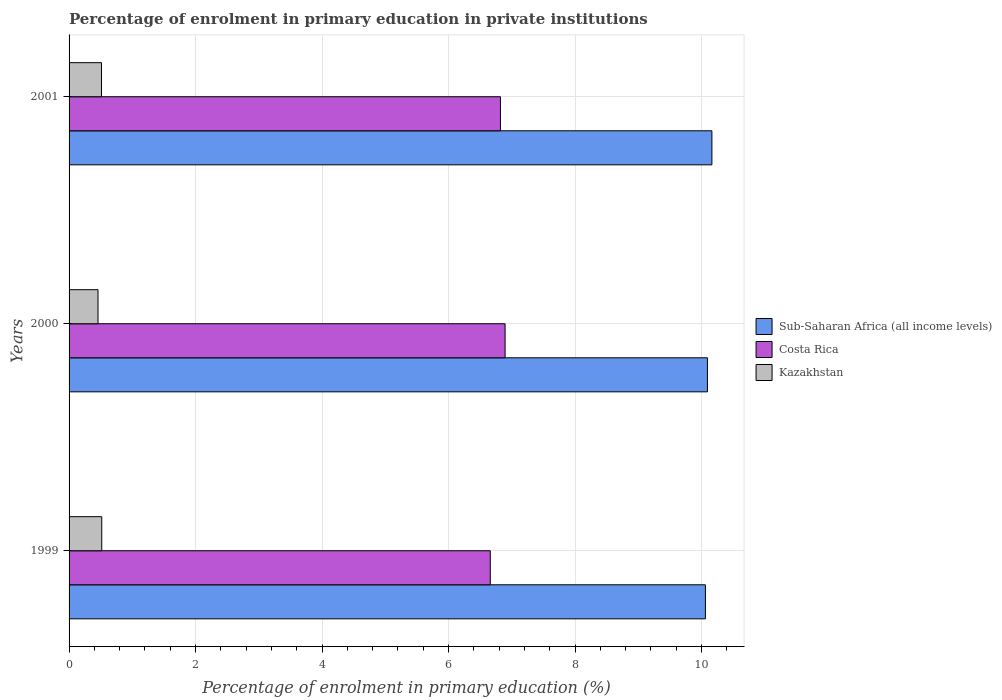How many groups of bars are there?
Your answer should be very brief. 3. Are the number of bars per tick equal to the number of legend labels?
Your response must be concise. Yes. Are the number of bars on each tick of the Y-axis equal?
Your response must be concise. Yes. How many bars are there on the 2nd tick from the top?
Offer a very short reply. 3. What is the label of the 1st group of bars from the top?
Your answer should be compact. 2001. What is the percentage of enrolment in primary education in Costa Rica in 2001?
Keep it short and to the point. 6.82. Across all years, what is the maximum percentage of enrolment in primary education in Sub-Saharan Africa (all income levels)?
Provide a succinct answer. 10.16. Across all years, what is the minimum percentage of enrolment in primary education in Costa Rica?
Your answer should be very brief. 6.66. What is the total percentage of enrolment in primary education in Kazakhstan in the graph?
Make the answer very short. 1.49. What is the difference between the percentage of enrolment in primary education in Costa Rica in 2000 and that in 2001?
Offer a terse response. 0.07. What is the difference between the percentage of enrolment in primary education in Sub-Saharan Africa (all income levels) in 2000 and the percentage of enrolment in primary education in Costa Rica in 2001?
Your answer should be very brief. 3.27. What is the average percentage of enrolment in primary education in Kazakhstan per year?
Make the answer very short. 0.5. In the year 2000, what is the difference between the percentage of enrolment in primary education in Costa Rica and percentage of enrolment in primary education in Kazakhstan?
Offer a terse response. 6.44. What is the ratio of the percentage of enrolment in primary education in Kazakhstan in 2000 to that in 2001?
Provide a succinct answer. 0.89. Is the difference between the percentage of enrolment in primary education in Costa Rica in 1999 and 2001 greater than the difference between the percentage of enrolment in primary education in Kazakhstan in 1999 and 2001?
Make the answer very short. No. What is the difference between the highest and the second highest percentage of enrolment in primary education in Sub-Saharan Africa (all income levels)?
Your answer should be very brief. 0.07. What is the difference between the highest and the lowest percentage of enrolment in primary education in Costa Rica?
Your answer should be compact. 0.23. In how many years, is the percentage of enrolment in primary education in Kazakhstan greater than the average percentage of enrolment in primary education in Kazakhstan taken over all years?
Your answer should be very brief. 2. What does the 1st bar from the top in 2001 represents?
Ensure brevity in your answer.  Kazakhstan. Is it the case that in every year, the sum of the percentage of enrolment in primary education in Sub-Saharan Africa (all income levels) and percentage of enrolment in primary education in Costa Rica is greater than the percentage of enrolment in primary education in Kazakhstan?
Your answer should be very brief. Yes. How many bars are there?
Give a very brief answer. 9. Are all the bars in the graph horizontal?
Your response must be concise. Yes. How many years are there in the graph?
Offer a terse response. 3. Are the values on the major ticks of X-axis written in scientific E-notation?
Your response must be concise. No. Does the graph contain grids?
Make the answer very short. Yes. How are the legend labels stacked?
Your answer should be very brief. Vertical. What is the title of the graph?
Make the answer very short. Percentage of enrolment in primary education in private institutions. What is the label or title of the X-axis?
Your response must be concise. Percentage of enrolment in primary education (%). What is the label or title of the Y-axis?
Your answer should be very brief. Years. What is the Percentage of enrolment in primary education (%) in Sub-Saharan Africa (all income levels) in 1999?
Keep it short and to the point. 10.06. What is the Percentage of enrolment in primary education (%) of Costa Rica in 1999?
Provide a succinct answer. 6.66. What is the Percentage of enrolment in primary education (%) in Kazakhstan in 1999?
Your answer should be compact. 0.52. What is the Percentage of enrolment in primary education (%) in Sub-Saharan Africa (all income levels) in 2000?
Provide a short and direct response. 10.09. What is the Percentage of enrolment in primary education (%) of Costa Rica in 2000?
Keep it short and to the point. 6.89. What is the Percentage of enrolment in primary education (%) of Kazakhstan in 2000?
Ensure brevity in your answer.  0.46. What is the Percentage of enrolment in primary education (%) of Sub-Saharan Africa (all income levels) in 2001?
Offer a terse response. 10.16. What is the Percentage of enrolment in primary education (%) in Costa Rica in 2001?
Your answer should be compact. 6.82. What is the Percentage of enrolment in primary education (%) of Kazakhstan in 2001?
Offer a very short reply. 0.51. Across all years, what is the maximum Percentage of enrolment in primary education (%) in Sub-Saharan Africa (all income levels)?
Keep it short and to the point. 10.16. Across all years, what is the maximum Percentage of enrolment in primary education (%) in Costa Rica?
Provide a short and direct response. 6.89. Across all years, what is the maximum Percentage of enrolment in primary education (%) in Kazakhstan?
Your answer should be compact. 0.52. Across all years, what is the minimum Percentage of enrolment in primary education (%) in Sub-Saharan Africa (all income levels)?
Make the answer very short. 10.06. Across all years, what is the minimum Percentage of enrolment in primary education (%) of Costa Rica?
Your answer should be compact. 6.66. Across all years, what is the minimum Percentage of enrolment in primary education (%) of Kazakhstan?
Your answer should be compact. 0.46. What is the total Percentage of enrolment in primary education (%) of Sub-Saharan Africa (all income levels) in the graph?
Your answer should be very brief. 30.32. What is the total Percentage of enrolment in primary education (%) in Costa Rica in the graph?
Provide a short and direct response. 20.37. What is the total Percentage of enrolment in primary education (%) in Kazakhstan in the graph?
Ensure brevity in your answer.  1.49. What is the difference between the Percentage of enrolment in primary education (%) in Sub-Saharan Africa (all income levels) in 1999 and that in 2000?
Give a very brief answer. -0.03. What is the difference between the Percentage of enrolment in primary education (%) of Costa Rica in 1999 and that in 2000?
Your answer should be very brief. -0.23. What is the difference between the Percentage of enrolment in primary education (%) of Kazakhstan in 1999 and that in 2000?
Ensure brevity in your answer.  0.06. What is the difference between the Percentage of enrolment in primary education (%) in Sub-Saharan Africa (all income levels) in 1999 and that in 2001?
Ensure brevity in your answer.  -0.1. What is the difference between the Percentage of enrolment in primary education (%) in Costa Rica in 1999 and that in 2001?
Make the answer very short. -0.16. What is the difference between the Percentage of enrolment in primary education (%) of Kazakhstan in 1999 and that in 2001?
Provide a succinct answer. 0. What is the difference between the Percentage of enrolment in primary education (%) in Sub-Saharan Africa (all income levels) in 2000 and that in 2001?
Your response must be concise. -0.07. What is the difference between the Percentage of enrolment in primary education (%) of Costa Rica in 2000 and that in 2001?
Your answer should be compact. 0.07. What is the difference between the Percentage of enrolment in primary education (%) of Kazakhstan in 2000 and that in 2001?
Offer a terse response. -0.05. What is the difference between the Percentage of enrolment in primary education (%) in Sub-Saharan Africa (all income levels) in 1999 and the Percentage of enrolment in primary education (%) in Costa Rica in 2000?
Provide a succinct answer. 3.17. What is the difference between the Percentage of enrolment in primary education (%) of Sub-Saharan Africa (all income levels) in 1999 and the Percentage of enrolment in primary education (%) of Kazakhstan in 2000?
Your answer should be compact. 9.6. What is the difference between the Percentage of enrolment in primary education (%) of Costa Rica in 1999 and the Percentage of enrolment in primary education (%) of Kazakhstan in 2000?
Give a very brief answer. 6.2. What is the difference between the Percentage of enrolment in primary education (%) of Sub-Saharan Africa (all income levels) in 1999 and the Percentage of enrolment in primary education (%) of Costa Rica in 2001?
Offer a very short reply. 3.24. What is the difference between the Percentage of enrolment in primary education (%) in Sub-Saharan Africa (all income levels) in 1999 and the Percentage of enrolment in primary education (%) in Kazakhstan in 2001?
Offer a terse response. 9.55. What is the difference between the Percentage of enrolment in primary education (%) of Costa Rica in 1999 and the Percentage of enrolment in primary education (%) of Kazakhstan in 2001?
Provide a succinct answer. 6.15. What is the difference between the Percentage of enrolment in primary education (%) of Sub-Saharan Africa (all income levels) in 2000 and the Percentage of enrolment in primary education (%) of Costa Rica in 2001?
Your response must be concise. 3.27. What is the difference between the Percentage of enrolment in primary education (%) of Sub-Saharan Africa (all income levels) in 2000 and the Percentage of enrolment in primary education (%) of Kazakhstan in 2001?
Provide a short and direct response. 9.58. What is the difference between the Percentage of enrolment in primary education (%) of Costa Rica in 2000 and the Percentage of enrolment in primary education (%) of Kazakhstan in 2001?
Offer a very short reply. 6.38. What is the average Percentage of enrolment in primary education (%) in Sub-Saharan Africa (all income levels) per year?
Your answer should be very brief. 10.11. What is the average Percentage of enrolment in primary education (%) of Costa Rica per year?
Provide a succinct answer. 6.79. What is the average Percentage of enrolment in primary education (%) in Kazakhstan per year?
Provide a short and direct response. 0.5. In the year 1999, what is the difference between the Percentage of enrolment in primary education (%) in Sub-Saharan Africa (all income levels) and Percentage of enrolment in primary education (%) in Costa Rica?
Ensure brevity in your answer.  3.4. In the year 1999, what is the difference between the Percentage of enrolment in primary education (%) in Sub-Saharan Africa (all income levels) and Percentage of enrolment in primary education (%) in Kazakhstan?
Your response must be concise. 9.54. In the year 1999, what is the difference between the Percentage of enrolment in primary education (%) of Costa Rica and Percentage of enrolment in primary education (%) of Kazakhstan?
Keep it short and to the point. 6.14. In the year 2000, what is the difference between the Percentage of enrolment in primary education (%) of Sub-Saharan Africa (all income levels) and Percentage of enrolment in primary education (%) of Costa Rica?
Keep it short and to the point. 3.2. In the year 2000, what is the difference between the Percentage of enrolment in primary education (%) in Sub-Saharan Africa (all income levels) and Percentage of enrolment in primary education (%) in Kazakhstan?
Provide a succinct answer. 9.64. In the year 2000, what is the difference between the Percentage of enrolment in primary education (%) of Costa Rica and Percentage of enrolment in primary education (%) of Kazakhstan?
Your answer should be very brief. 6.44. In the year 2001, what is the difference between the Percentage of enrolment in primary education (%) of Sub-Saharan Africa (all income levels) and Percentage of enrolment in primary education (%) of Costa Rica?
Your answer should be very brief. 3.34. In the year 2001, what is the difference between the Percentage of enrolment in primary education (%) of Sub-Saharan Africa (all income levels) and Percentage of enrolment in primary education (%) of Kazakhstan?
Ensure brevity in your answer.  9.65. In the year 2001, what is the difference between the Percentage of enrolment in primary education (%) of Costa Rica and Percentage of enrolment in primary education (%) of Kazakhstan?
Keep it short and to the point. 6.31. What is the ratio of the Percentage of enrolment in primary education (%) in Sub-Saharan Africa (all income levels) in 1999 to that in 2000?
Your answer should be very brief. 1. What is the ratio of the Percentage of enrolment in primary education (%) of Kazakhstan in 1999 to that in 2000?
Your response must be concise. 1.13. What is the ratio of the Percentage of enrolment in primary education (%) in Sub-Saharan Africa (all income levels) in 1999 to that in 2001?
Your answer should be very brief. 0.99. What is the ratio of the Percentage of enrolment in primary education (%) of Costa Rica in 1999 to that in 2001?
Ensure brevity in your answer.  0.98. What is the ratio of the Percentage of enrolment in primary education (%) of Kazakhstan in 1999 to that in 2001?
Your answer should be compact. 1.01. What is the ratio of the Percentage of enrolment in primary education (%) in Costa Rica in 2000 to that in 2001?
Provide a short and direct response. 1.01. What is the ratio of the Percentage of enrolment in primary education (%) in Kazakhstan in 2000 to that in 2001?
Your response must be concise. 0.89. What is the difference between the highest and the second highest Percentage of enrolment in primary education (%) of Sub-Saharan Africa (all income levels)?
Offer a terse response. 0.07. What is the difference between the highest and the second highest Percentage of enrolment in primary education (%) of Costa Rica?
Make the answer very short. 0.07. What is the difference between the highest and the second highest Percentage of enrolment in primary education (%) in Kazakhstan?
Offer a terse response. 0. What is the difference between the highest and the lowest Percentage of enrolment in primary education (%) in Sub-Saharan Africa (all income levels)?
Keep it short and to the point. 0.1. What is the difference between the highest and the lowest Percentage of enrolment in primary education (%) of Costa Rica?
Offer a terse response. 0.23. What is the difference between the highest and the lowest Percentage of enrolment in primary education (%) of Kazakhstan?
Your answer should be very brief. 0.06. 